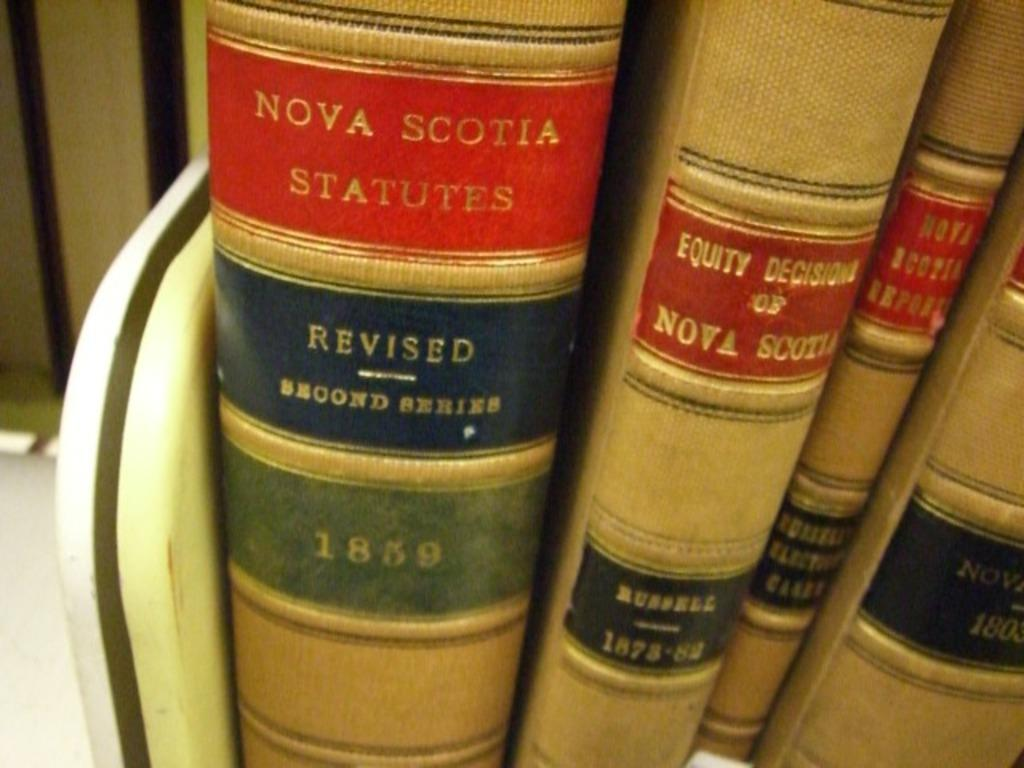Provide a one-sentence caption for the provided image. Nova Scotia legal information is in books with spines visible. 